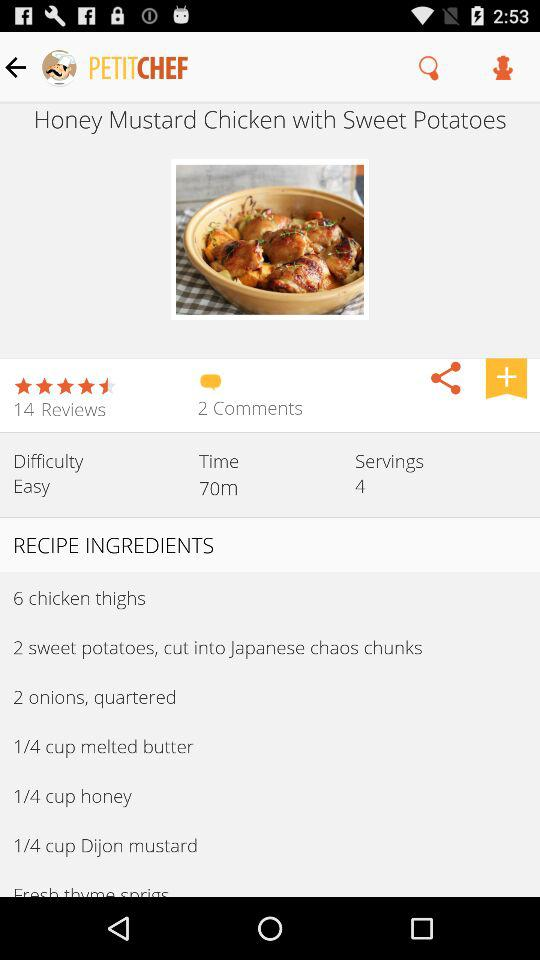What is the rating of the dish? The rating is 4.5 stars. 